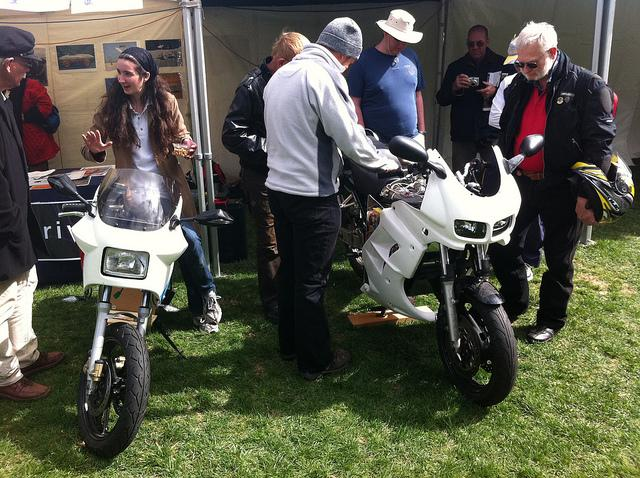What animal is the same color as the bike? polar bear 